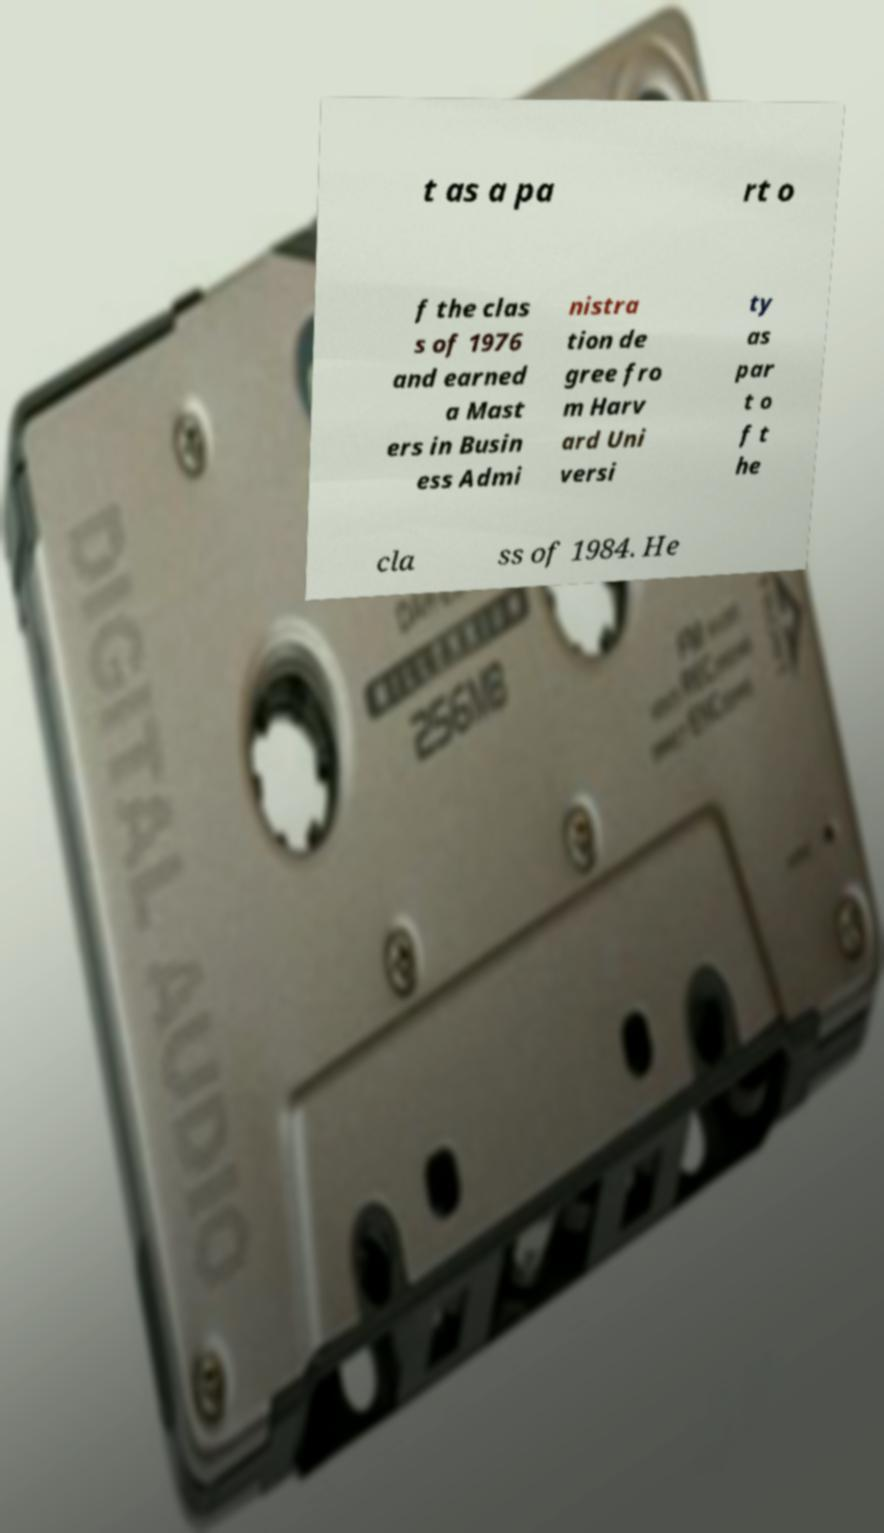There's text embedded in this image that I need extracted. Can you transcribe it verbatim? t as a pa rt o f the clas s of 1976 and earned a Mast ers in Busin ess Admi nistra tion de gree fro m Harv ard Uni versi ty as par t o f t he cla ss of 1984. He 